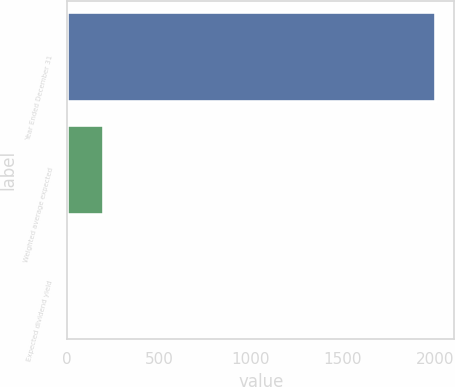<chart> <loc_0><loc_0><loc_500><loc_500><bar_chart><fcel>Year Ended December 31<fcel>Weighted average expected<fcel>Expected dividend yield<nl><fcel>2007<fcel>202.05<fcel>1.5<nl></chart> 